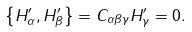<formula> <loc_0><loc_0><loc_500><loc_500>\left \{ H _ { \alpha } ^ { \prime } , H _ { \beta } ^ { \prime } \right \} = C _ { \alpha \beta \gamma } H _ { \gamma } ^ { \prime } = 0 .</formula> 